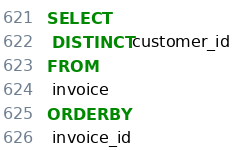Convert code to text. <code><loc_0><loc_0><loc_500><loc_500><_SQL_>SELECT
 DISTINCT customer_id
FROM
 invoice
ORDER BY
 invoice_id</code> 